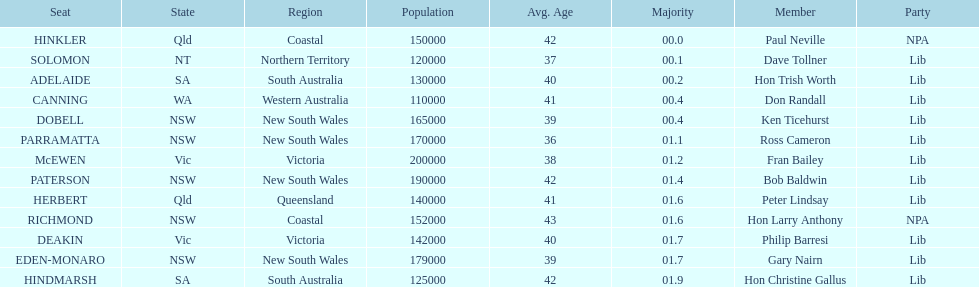Was fran bailey from vic or wa? Vic. 